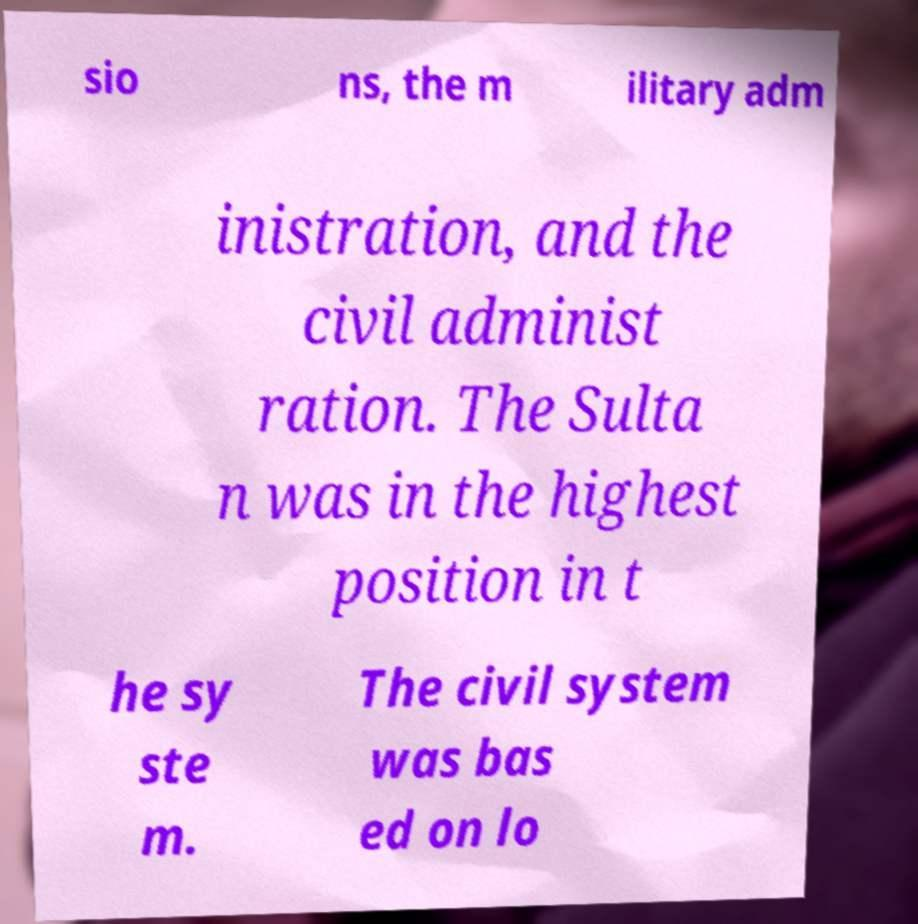What messages or text are displayed in this image? I need them in a readable, typed format. sio ns, the m ilitary adm inistration, and the civil administ ration. The Sulta n was in the highest position in t he sy ste m. The civil system was bas ed on lo 